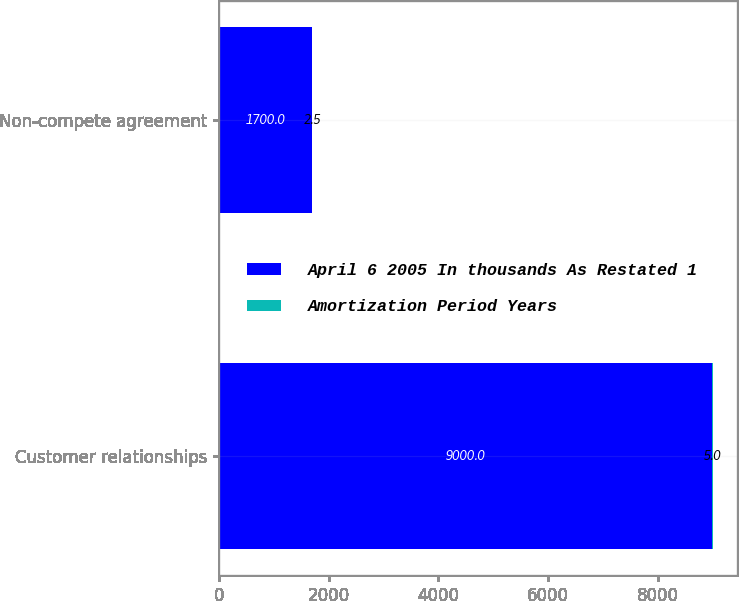Convert chart. <chart><loc_0><loc_0><loc_500><loc_500><stacked_bar_chart><ecel><fcel>Customer relationships<fcel>Non-compete agreement<nl><fcel>April 6 2005 In thousands As Restated 1<fcel>9000<fcel>1700<nl><fcel>Amortization Period Years<fcel>5<fcel>2.5<nl></chart> 